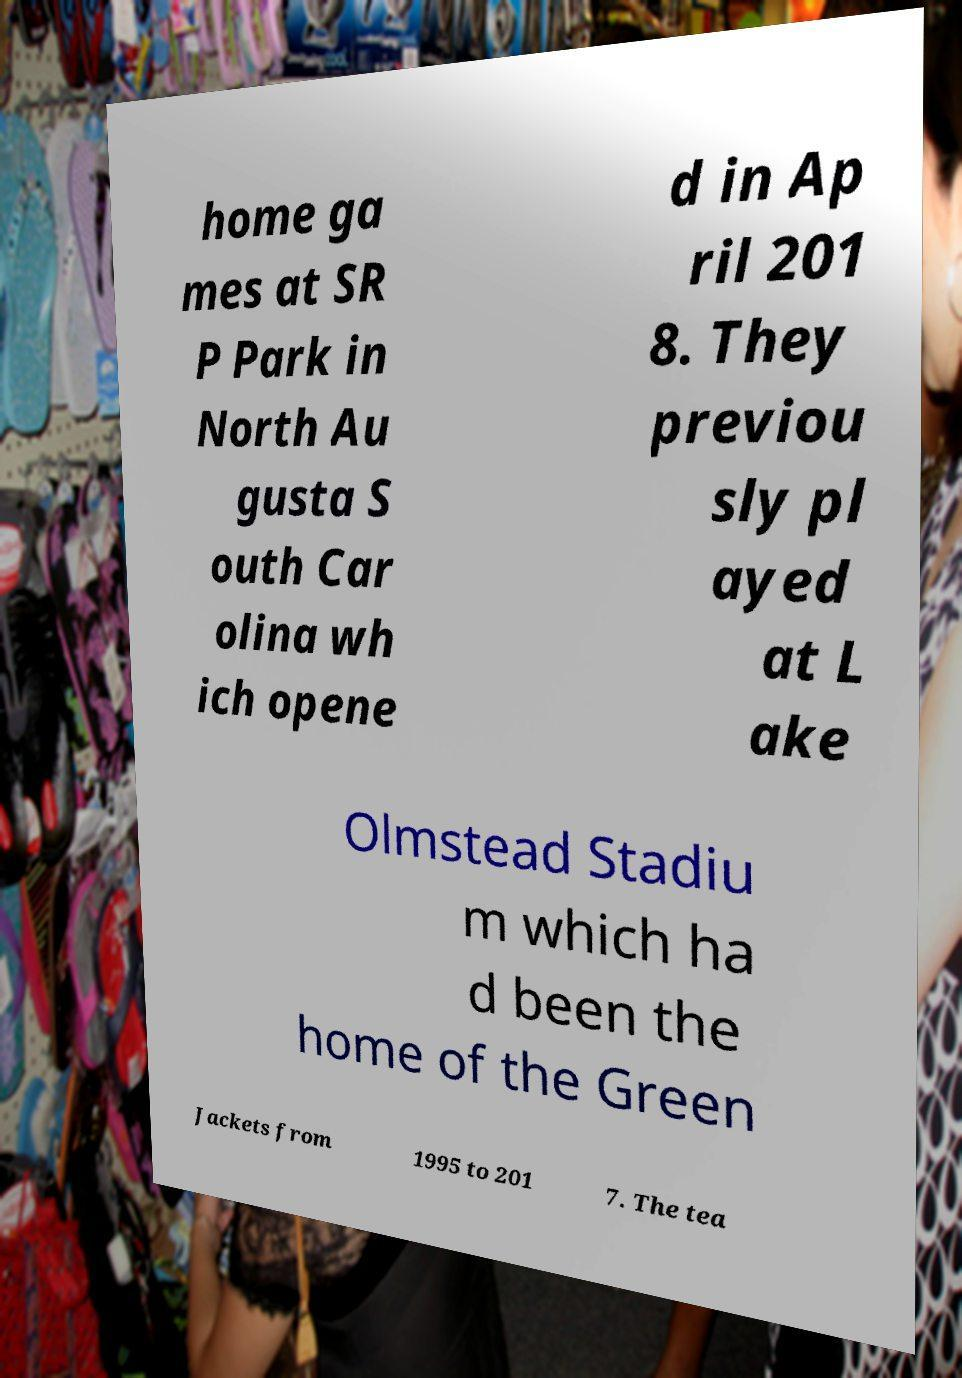Can you accurately transcribe the text from the provided image for me? home ga mes at SR P Park in North Au gusta S outh Car olina wh ich opene d in Ap ril 201 8. They previou sly pl ayed at L ake Olmstead Stadiu m which ha d been the home of the Green Jackets from 1995 to 201 7. The tea 